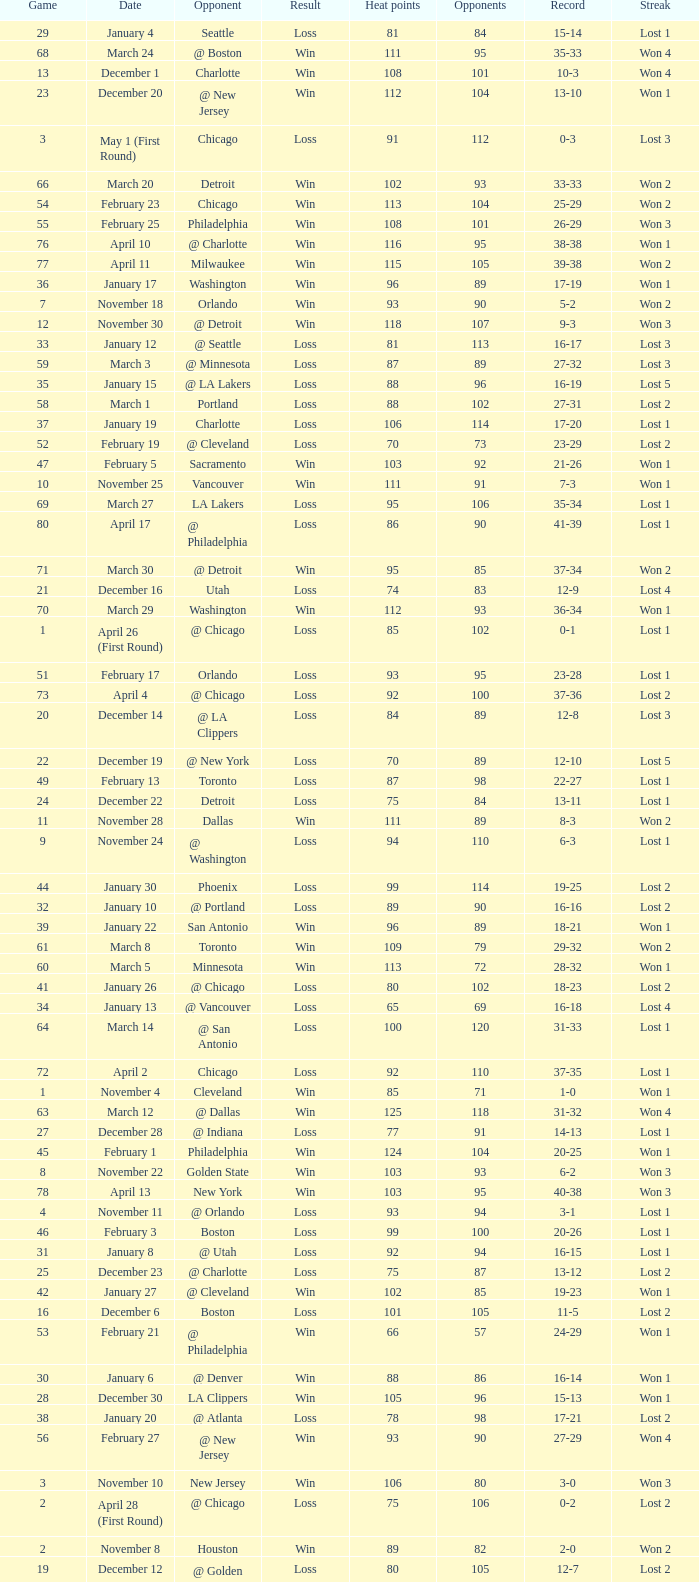What is Streak, when Heat Points is "101", and when Game is "16"? Lost 2. 